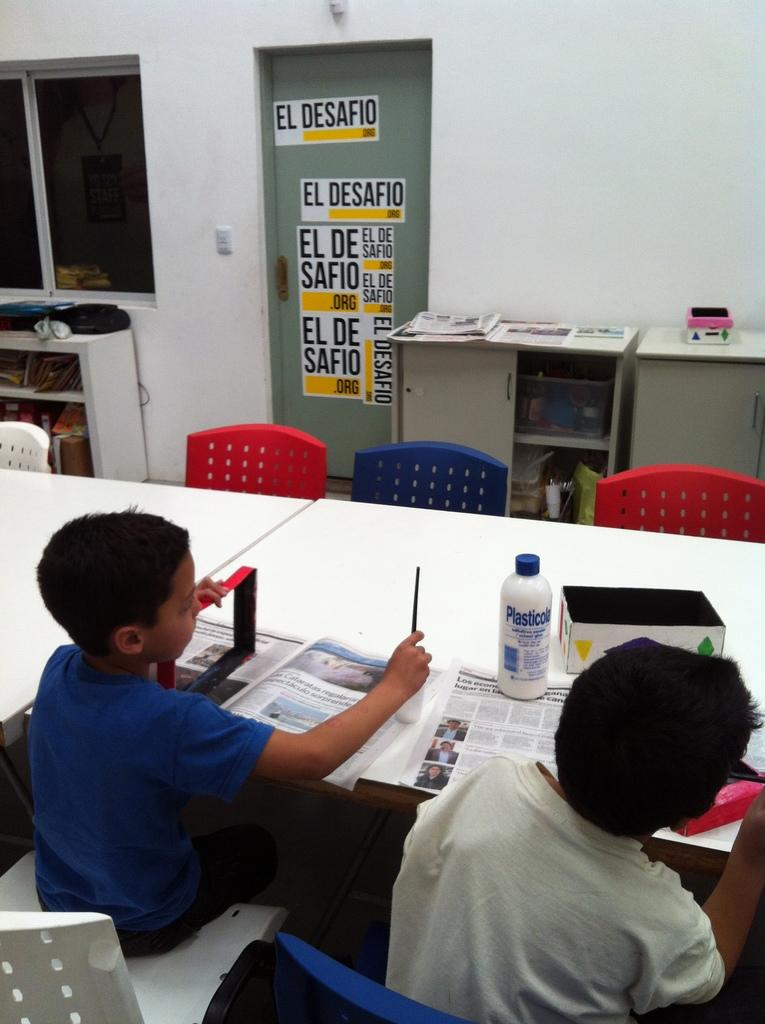<image>
Describe the image concisely. the word desafio that is on the wall 